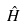<formula> <loc_0><loc_0><loc_500><loc_500>\hat { H }</formula> 